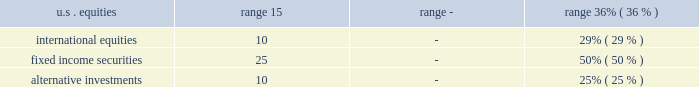Pension plan assets pension assets include public equities , government and corporate bonds , cash and cash equivalents , private real estate funds , private partnerships , hedge funds , and other assets .
Plan assets are held in a master trust and overseen by the company's investment committee .
All assets are externally managed through a combination of active and passive strategies .
Managers may only invest in the asset classes for which they have been appointed .
The investment committee is responsible for setting the policy that provides the framework for management of the plan assets .
The investment committee has set the minimum and maximum permitted values for each asset class in the company's pension plan master trust for the year ended december 31 , 2018 , as follows: .
The general objectives of the company's pension asset strategy are to earn a rate of return over time to satisfy the benefit obligations of the plans , meet minimum erisa funding requirements , and maintain sufficient liquidity to pay benefits and address other cash requirements within the master trust .
Specific investment objectives include reducing the volatility of pension assets relative to benefit obligations , achieving a competitive , total investment return , achieving diversification between and within asset classes , and managing other risks .
Investment objectives for each asset class are determined based on specific risks and investment opportunities identified .
Decisions regarding investment policies and asset allocation are made with the understanding of the historical and prospective return and risk characteristics of various asset classes , the effect of asset allocations on funded status , future company contributions , and projected expenditures , including benefits .
The company updates its asset allocations periodically .
The company uses various analytics to determine the optimal asset mix and considers plan obligation characteristics , duration , liquidity characteristics , funding requirements , expected rates of return , regular rebalancing , and the distribution of returns .
Actual allocations to each asset class could vary from target allocations due to periodic investment strategy changes , short-term market value fluctuations , the length of time it takes to fully implement investment allocation positions , such as real estate and other alternative investments , and the timing of benefit payments and company contributions .
Taking into account the asset allocation ranges , the company determines the specific allocation of the master trust's investments within various asset classes .
The master trust utilizes select investment strategies , which are executed through separate account or fund structures with external investment managers who demonstrate experience and expertise in the appropriate asset classes and styles .
The selection of investment managers is done with careful evaluation of all aspects of performance and risk , demonstrated fiduciary responsibility , investment management experience , and a review of the investment managers' policies and processes .
Investment performance is monitored frequently against appropriate benchmarks and tracked to compliance guidelines with the assistance of third party consultants and performance evaluation tools and metrics .
Plan assets are stated at fair value .
The company employs a variety of pricing sources to estimate the fair value of its pension plan assets , including independent pricing vendors , dealer or counterparty-supplied valuations , third- party appraisals , and appraisals prepared by the company's investment managers or other experts .
Investments in equity securities , common and preferred , are valued at the last reported sales price when an active market exists .
Securities for which official or last trade pricing on an active exchange is available are classified as level 1 .
If closing prices are not available , securities are valued at the last trade price , if deemed reasonable , or a broker's quote in a non-active market , and are typically categorized as level 2 .
Investments in fixed-income securities are generally valued by independent pricing services or dealers who make markets in such securities .
Pricing methods are based upon market transactions for comparable securities and various relationships between securities that are generally recognized by institutional traders , and fixed-income securities typically are categorized as level 2. .
What is the difference in the range of international equities permitted in the company's pension plan? 
Computations: (29% - 10)
Answer: -9.71. 